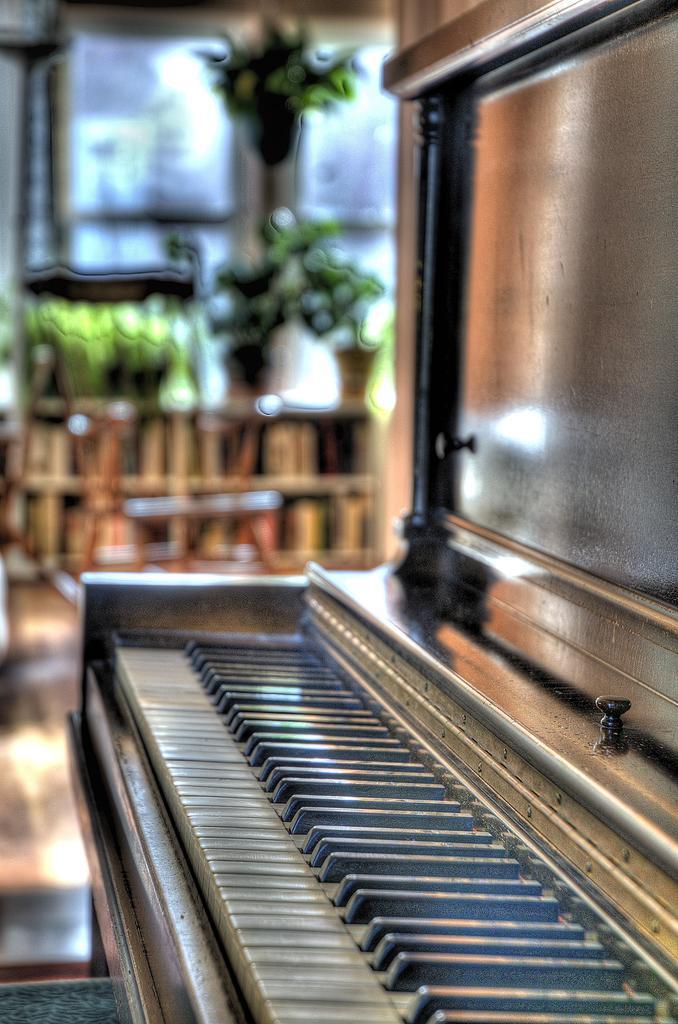How would you summarize this image in a sentence or two? This piano keyboard is highlighted in this picture. 